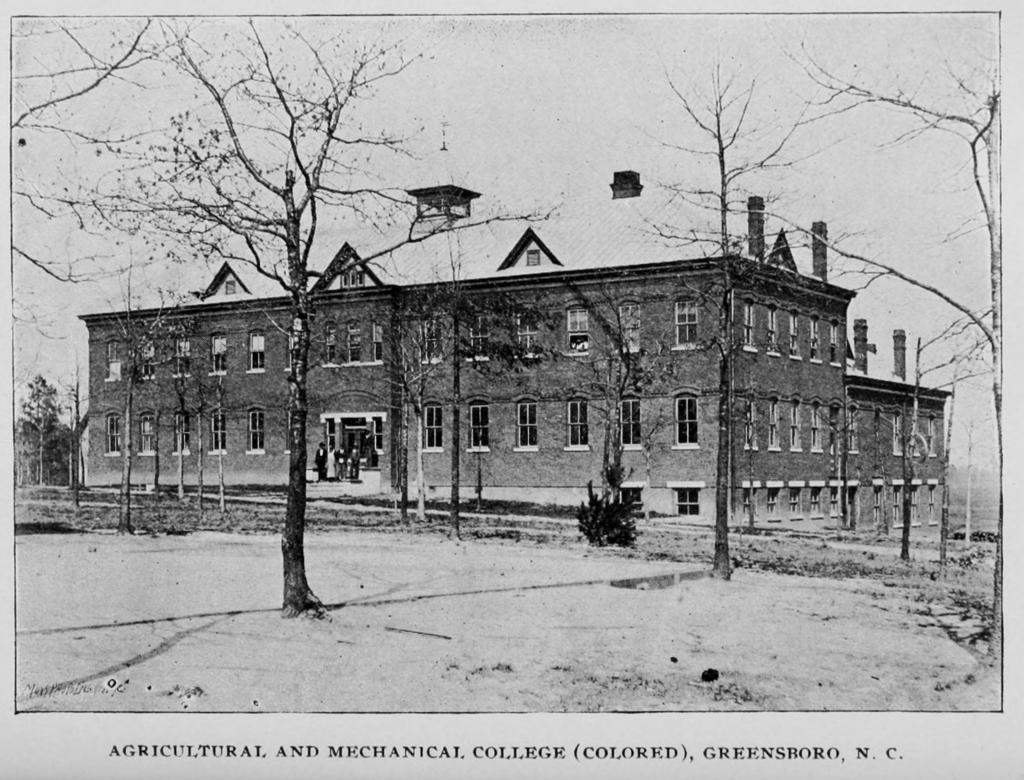What is the main subject of the poster in the image? The main subject of the poster in the image is a house. Where is the house located on the poster? The house is in the center of the poster. What features can be seen on the house? The house has windows. What else is visible in the image besides the poster? There are trees in the image. What type of coast can be seen in the image? There is no coast present in the image; it features a poster with a house and trees. How deep is the hole in the image? There is no hole present in the image. 